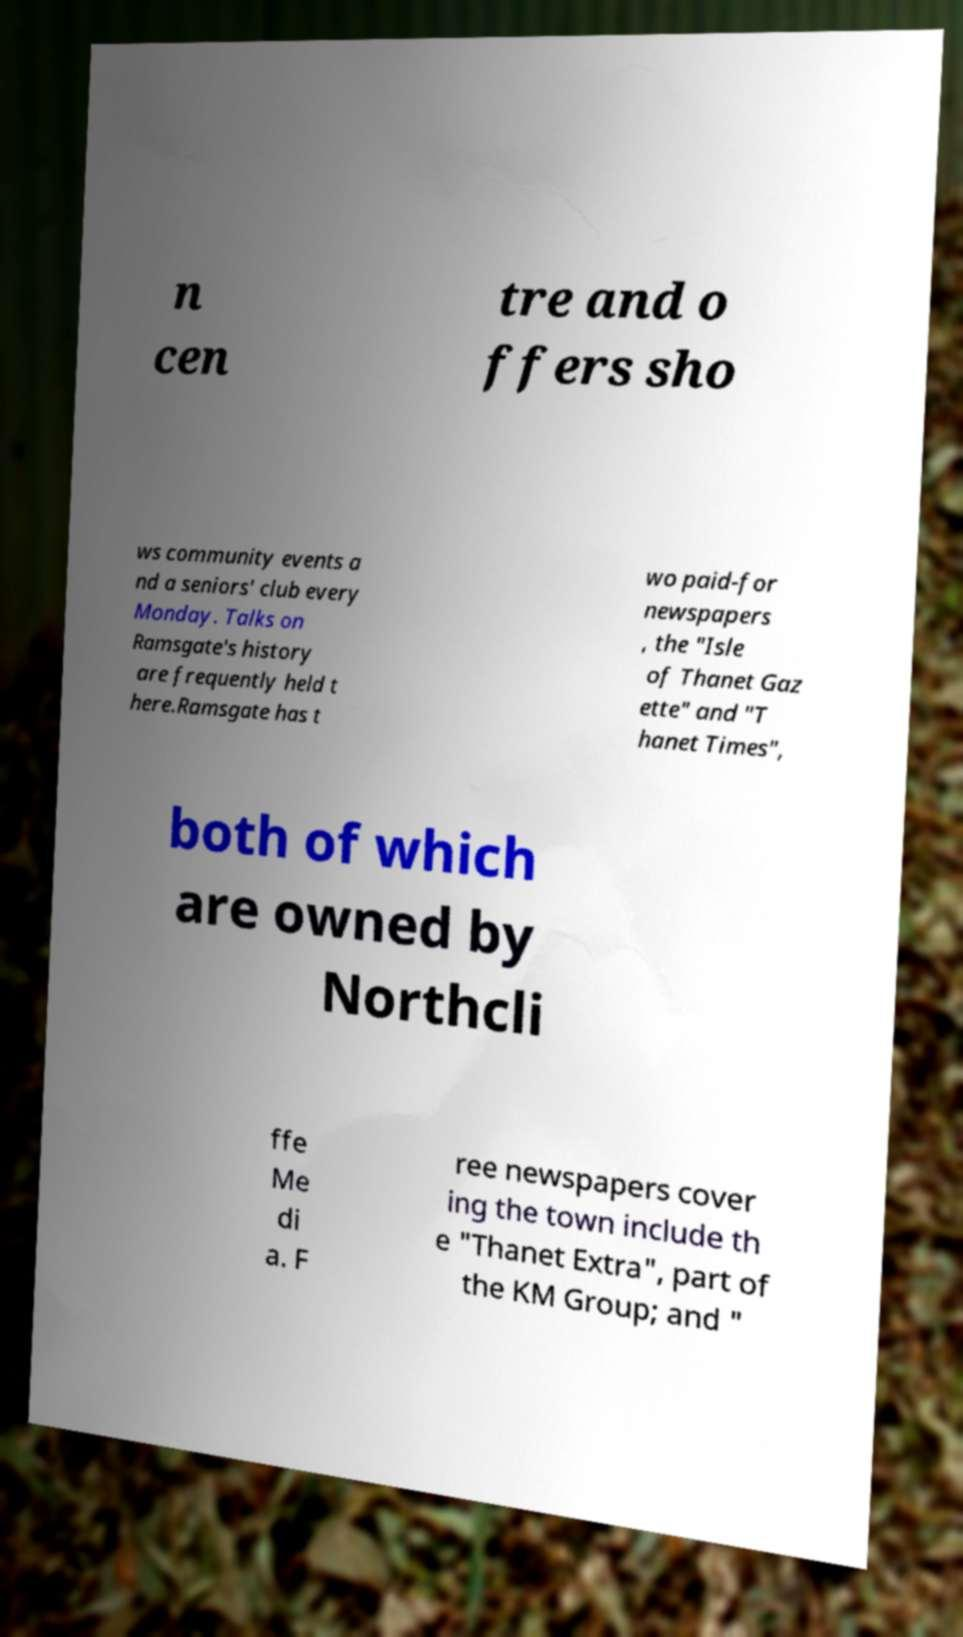What messages or text are displayed in this image? I need them in a readable, typed format. n cen tre and o ffers sho ws community events a nd a seniors' club every Monday. Talks on Ramsgate's history are frequently held t here.Ramsgate has t wo paid-for newspapers , the "Isle of Thanet Gaz ette" and "T hanet Times", both of which are owned by Northcli ffe Me di a. F ree newspapers cover ing the town include th e "Thanet Extra", part of the KM Group; and " 